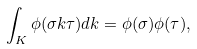Convert formula to latex. <formula><loc_0><loc_0><loc_500><loc_500>\int _ { K } \phi ( \sigma k \tau ) d k = \phi ( \sigma ) \phi ( \tau ) ,</formula> 